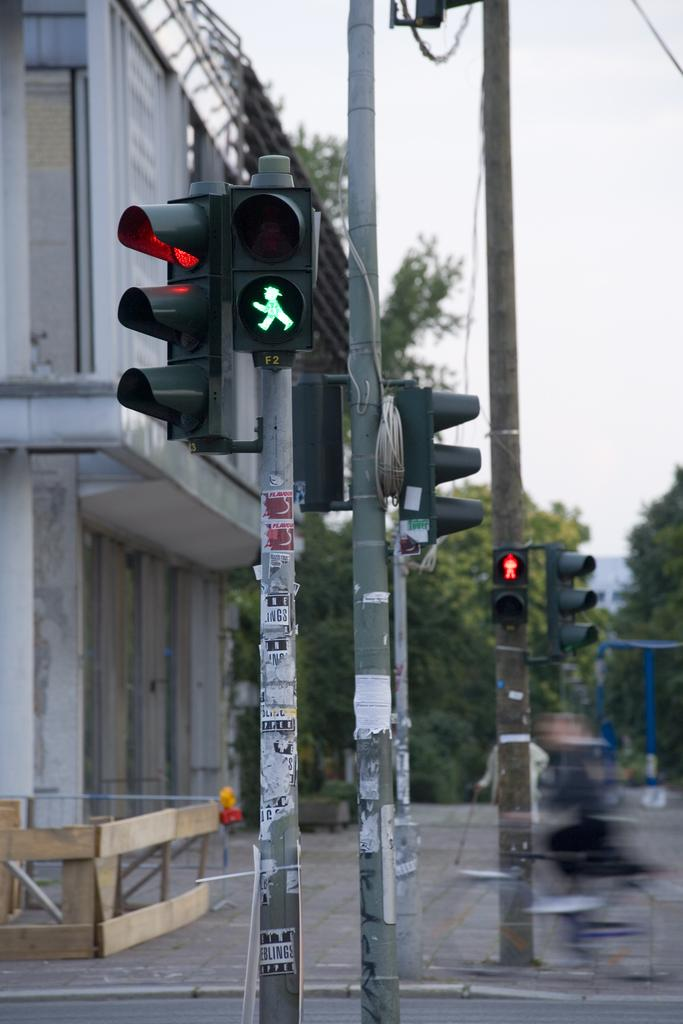What is located in the center of the image? There are poles in the center of the image. What structure can be seen on the left side of the image? There is a building on the left side of the image. What type of vegetation is present in the image? There are trees in the image. How would you describe the sky in the image? The sky is cloudy in the image. Can you see a crack in the building in the image? There is no mention of a crack in the building in the provided facts, so we cannot determine if one is present. Are there any mountains visible in the image? There is no mention of mountains in the provided facts, so we cannot determine if any are present. 